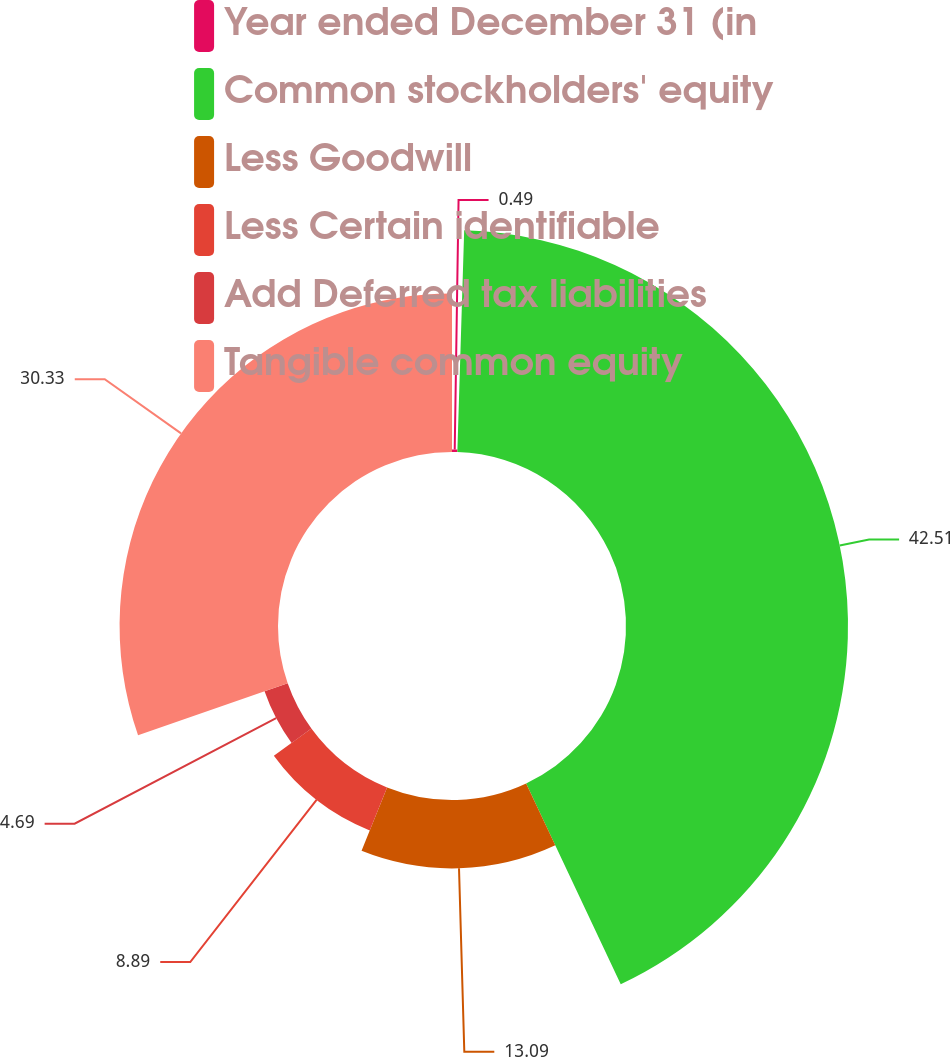Convert chart. <chart><loc_0><loc_0><loc_500><loc_500><pie_chart><fcel>Year ended December 31 (in<fcel>Common stockholders' equity<fcel>Less Goodwill<fcel>Less Certain identifiable<fcel>Add Deferred tax liabilities<fcel>Tangible common equity<nl><fcel>0.49%<fcel>42.5%<fcel>13.09%<fcel>8.89%<fcel>4.69%<fcel>30.33%<nl></chart> 